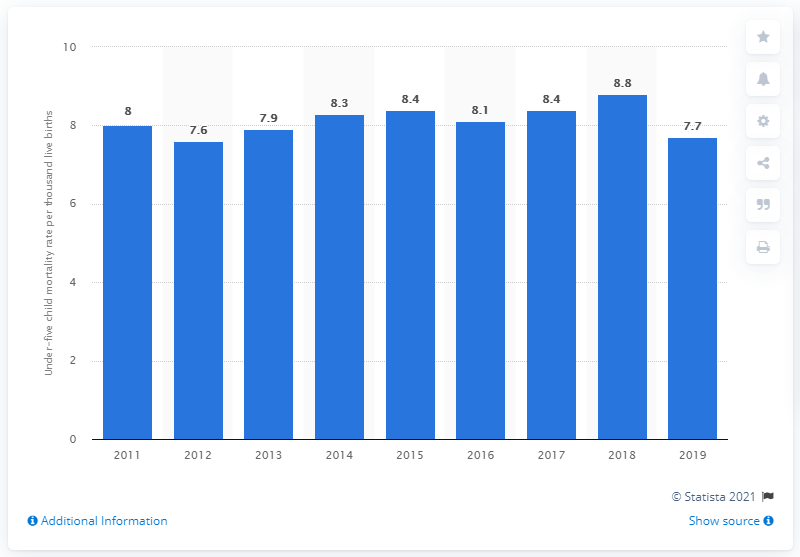Highlight a few significant elements in this photo. In 2019, the under five child mortality rate in Malaysia was 7.7%. 